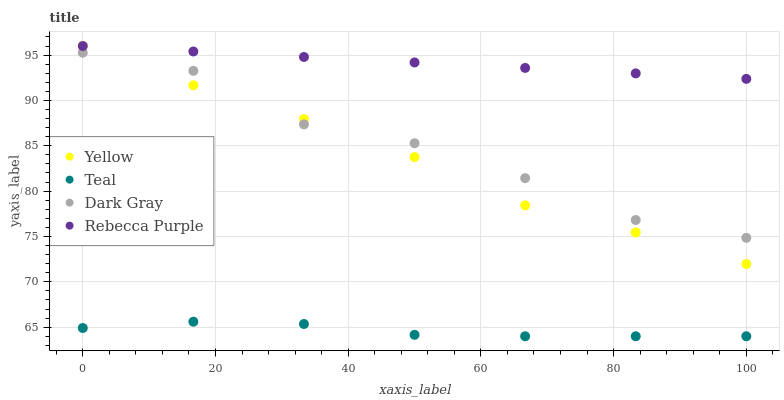Does Teal have the minimum area under the curve?
Answer yes or no. Yes. Does Rebecca Purple have the maximum area under the curve?
Answer yes or no. Yes. Does Yellow have the minimum area under the curve?
Answer yes or no. No. Does Yellow have the maximum area under the curve?
Answer yes or no. No. Is Rebecca Purple the smoothest?
Answer yes or no. Yes. Is Dark Gray the roughest?
Answer yes or no. Yes. Is Teal the smoothest?
Answer yes or no. No. Is Teal the roughest?
Answer yes or no. No. Does Teal have the lowest value?
Answer yes or no. Yes. Does Yellow have the lowest value?
Answer yes or no. No. Does Rebecca Purple have the highest value?
Answer yes or no. Yes. Does Teal have the highest value?
Answer yes or no. No. Is Dark Gray less than Rebecca Purple?
Answer yes or no. Yes. Is Dark Gray greater than Teal?
Answer yes or no. Yes. Does Yellow intersect Rebecca Purple?
Answer yes or no. Yes. Is Yellow less than Rebecca Purple?
Answer yes or no. No. Is Yellow greater than Rebecca Purple?
Answer yes or no. No. Does Dark Gray intersect Rebecca Purple?
Answer yes or no. No. 